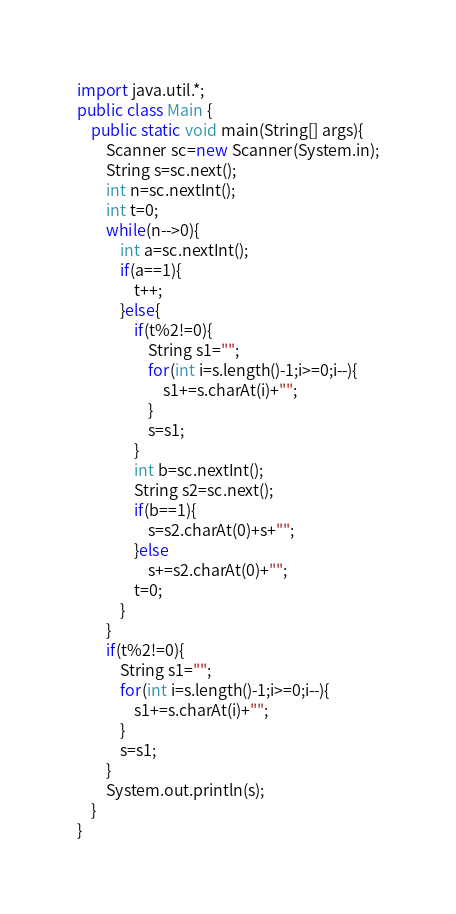<code> <loc_0><loc_0><loc_500><loc_500><_Java_>import java.util.*;
public class Main {
	public static void main(String[] args){
		Scanner sc=new Scanner(System.in);
		String s=sc.next();
		int n=sc.nextInt();
		int t=0;
		while(n-->0){
			int a=sc.nextInt();
			if(a==1){
				t++;
			}else{
				if(t%2!=0){
					String s1="";
					for(int i=s.length()-1;i>=0;i--){
						s1+=s.charAt(i)+"";
					}
					s=s1;
				}
				int b=sc.nextInt();
				String s2=sc.next();
				if(b==1){
					s=s2.charAt(0)+s+"";
				}else
					s+=s2.charAt(0)+"";
				t=0;
			}
		}
		if(t%2!=0){
			String s1="";
			for(int i=s.length()-1;i>=0;i--){
				s1+=s.charAt(i)+"";
			}
			s=s1;
		}
		System.out.println(s);
	}
}
</code> 